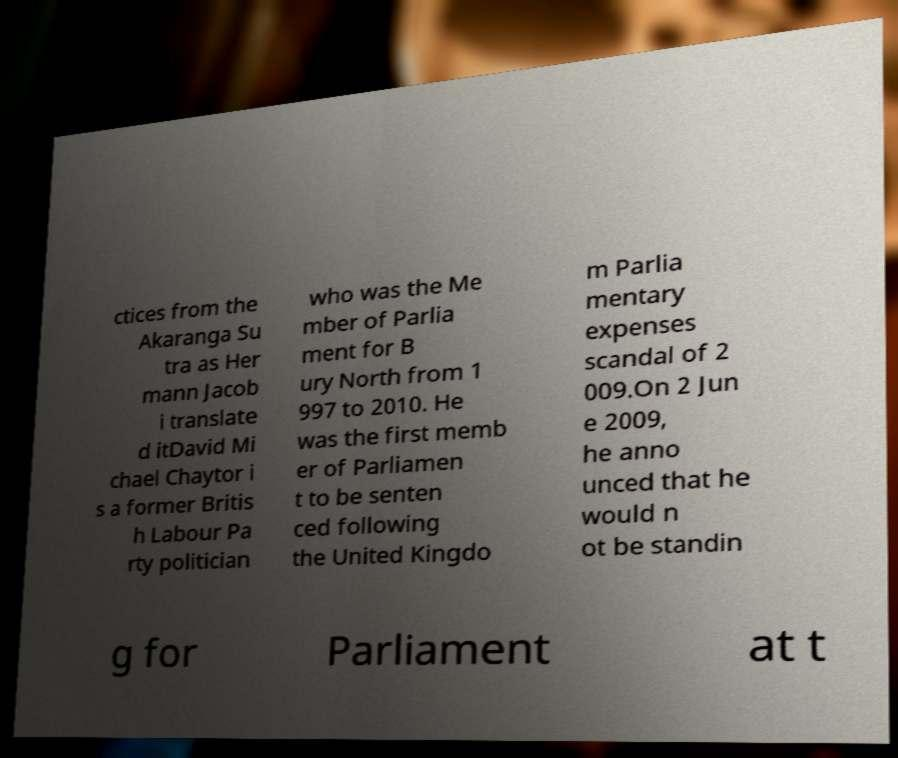Can you accurately transcribe the text from the provided image for me? ctices from the Akaranga Su tra as Her mann Jacob i translate d itDavid Mi chael Chaytor i s a former Britis h Labour Pa rty politician who was the Me mber of Parlia ment for B ury North from 1 997 to 2010. He was the first memb er of Parliamen t to be senten ced following the United Kingdo m Parlia mentary expenses scandal of 2 009.On 2 Jun e 2009, he anno unced that he would n ot be standin g for Parliament at t 